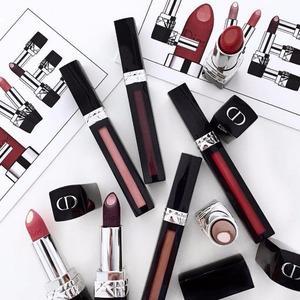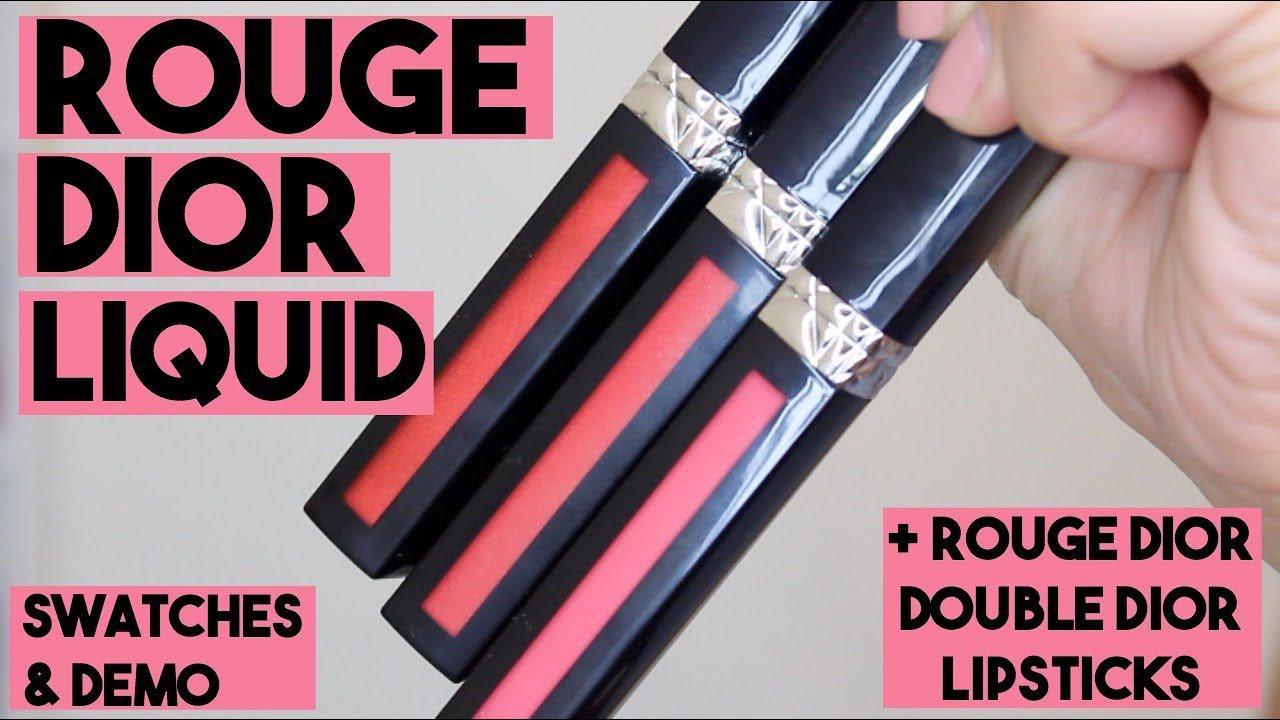The first image is the image on the left, the second image is the image on the right. Considering the images on both sides, is "An image shows a hand holding an opened lipstick." valid? Answer yes or no. No. The first image is the image on the left, the second image is the image on the right. Given the left and right images, does the statement "A human hand is holding a lipstick without a cap." hold true? Answer yes or no. No. 